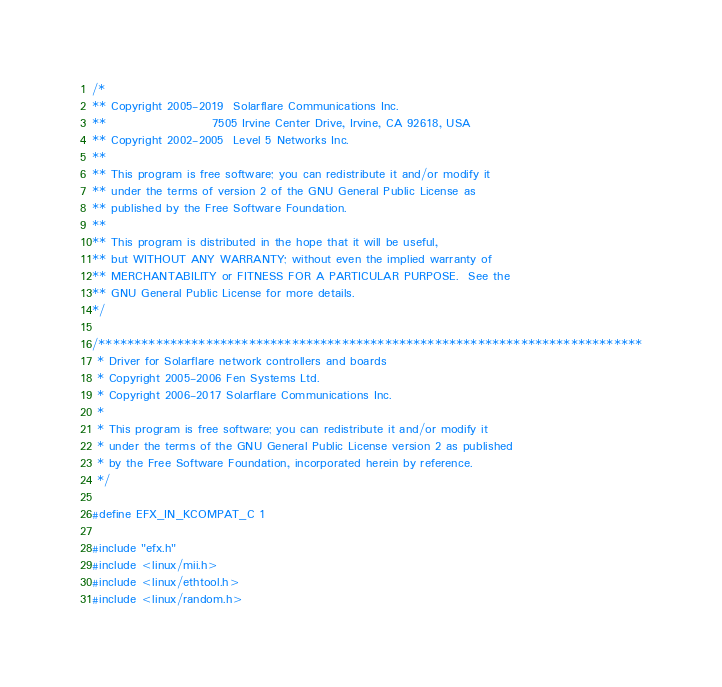<code> <loc_0><loc_0><loc_500><loc_500><_C_>/*
** Copyright 2005-2019  Solarflare Communications Inc.
**                      7505 Irvine Center Drive, Irvine, CA 92618, USA
** Copyright 2002-2005  Level 5 Networks Inc.
**
** This program is free software; you can redistribute it and/or modify it
** under the terms of version 2 of the GNU General Public License as
** published by the Free Software Foundation.
**
** This program is distributed in the hope that it will be useful,
** but WITHOUT ANY WARRANTY; without even the implied warranty of
** MERCHANTABILITY or FITNESS FOR A PARTICULAR PURPOSE.  See the
** GNU General Public License for more details.
*/

/****************************************************************************
 * Driver for Solarflare network controllers and boards
 * Copyright 2005-2006 Fen Systems Ltd.
 * Copyright 2006-2017 Solarflare Communications Inc.
 *
 * This program is free software; you can redistribute it and/or modify it
 * under the terms of the GNU General Public License version 2 as published
 * by the Free Software Foundation, incorporated herein by reference.
 */

#define EFX_IN_KCOMPAT_C 1

#include "efx.h"
#include <linux/mii.h>
#include <linux/ethtool.h>
#include <linux/random.h></code> 